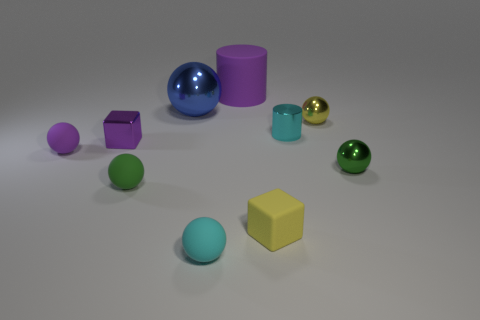What number of other objects are the same shape as the green rubber thing?
Make the answer very short. 5. Are there more objects in front of the green rubber sphere than purple metal blocks?
Make the answer very short. Yes. There is a purple object that is the same shape as the big blue thing; what is its size?
Give a very brief answer. Small. The cyan rubber thing is what shape?
Your answer should be compact. Sphere. There is a yellow shiny object that is the same size as the metallic cylinder; what is its shape?
Provide a succinct answer. Sphere. Are there any other things that have the same color as the large sphere?
Provide a succinct answer. No. What is the size of the purple block that is made of the same material as the large sphere?
Your response must be concise. Small. Do the big purple object and the shiny thing to the left of the big blue ball have the same shape?
Your answer should be very brief. No. The purple cube is what size?
Provide a succinct answer. Small. Is the number of purple balls on the right side of the small yellow matte object less than the number of red matte objects?
Offer a very short reply. No. 